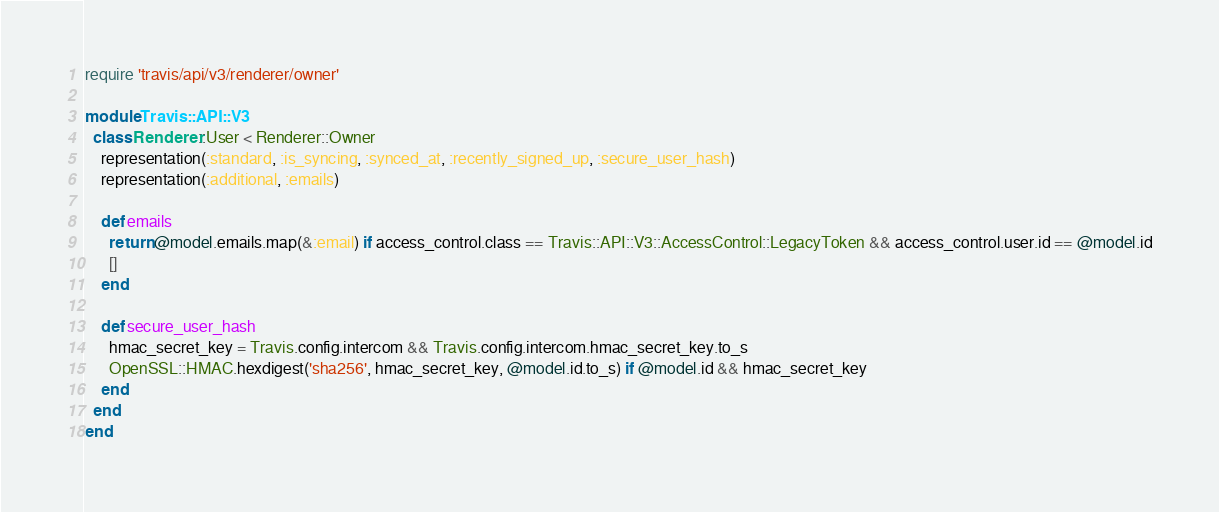Convert code to text. <code><loc_0><loc_0><loc_500><loc_500><_Ruby_>require 'travis/api/v3/renderer/owner'

module Travis::API::V3
  class Renderer::User < Renderer::Owner
    representation(:standard, :is_syncing, :synced_at, :recently_signed_up, :secure_user_hash)
    representation(:additional, :emails)

    def emails
      return @model.emails.map(&:email) if access_control.class == Travis::API::V3::AccessControl::LegacyToken && access_control.user.id == @model.id
      []
    end

    def secure_user_hash
      hmac_secret_key = Travis.config.intercom && Travis.config.intercom.hmac_secret_key.to_s
      OpenSSL::HMAC.hexdigest('sha256', hmac_secret_key, @model.id.to_s) if @model.id && hmac_secret_key
    end
  end
end
</code> 